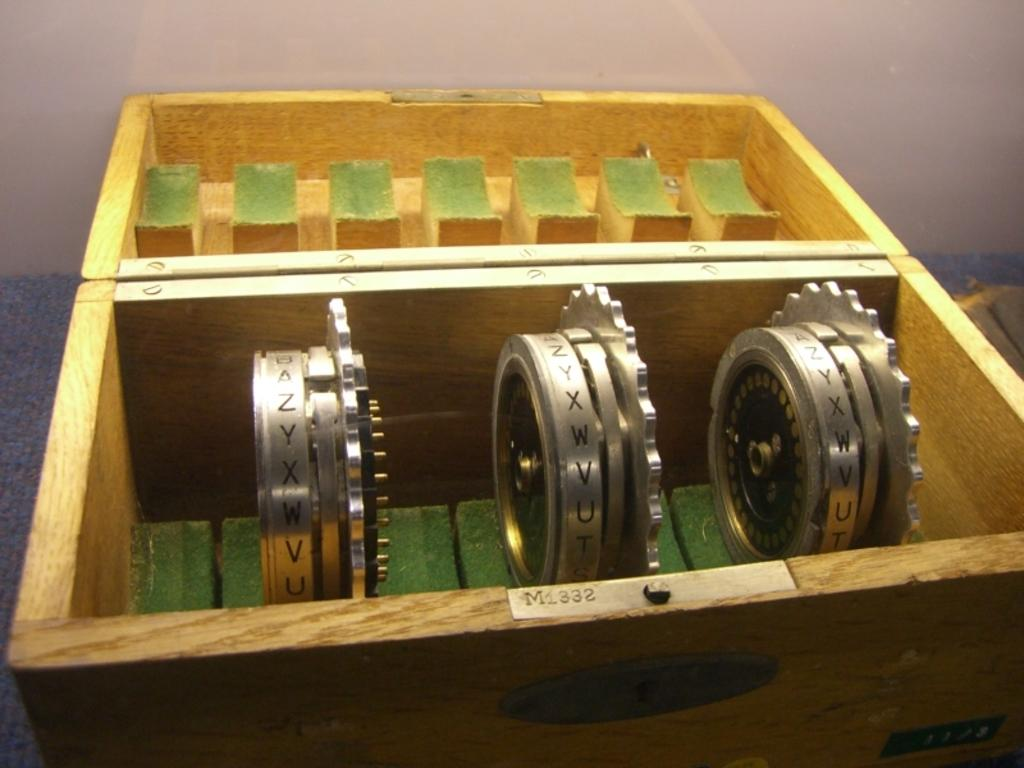What is inside the wooden box in the image? There are rotating gears in the wooden box. Can you describe the gears in the image? The gears are visible in the image. What is visible in the background of the image? There is a wall in the background of the image. How many sisters can be seen interacting with the gears in the image? There are no sisters present in the image; it features a wooden box with rotating gears and a wall in the background. 